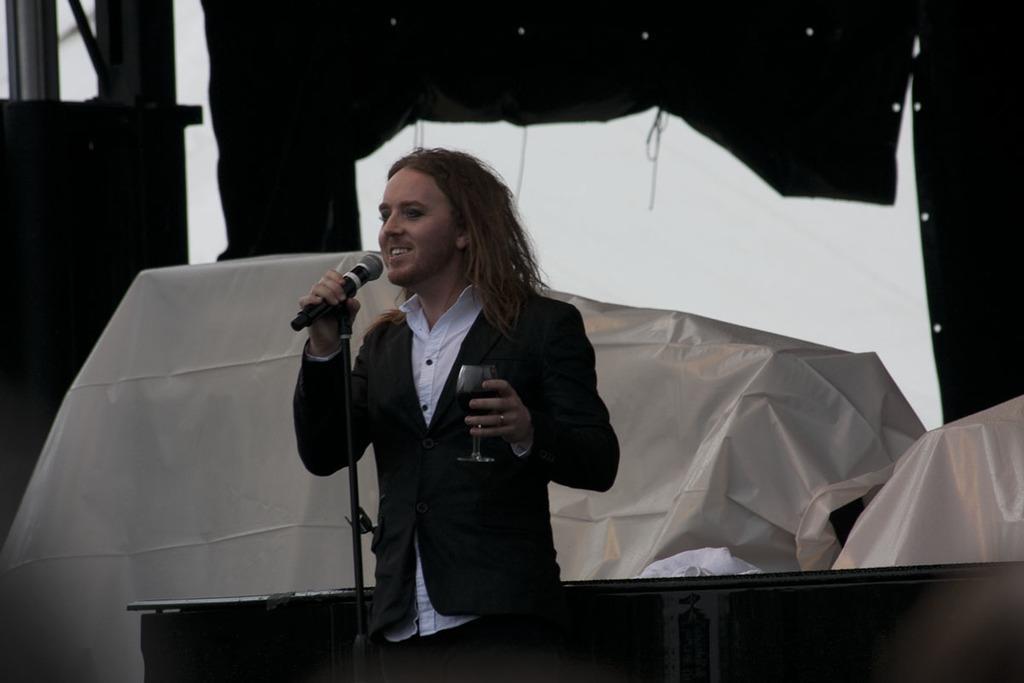Can you describe this image briefly? In this picture we can see a man standing and holding a microphone and a glass of drink, there is a mike stand in front of him, in the background there are some covers. 